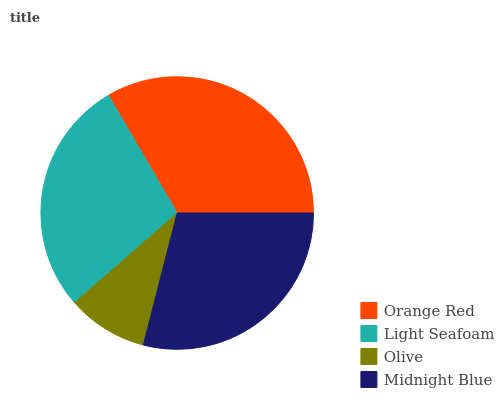Is Olive the minimum?
Answer yes or no. Yes. Is Orange Red the maximum?
Answer yes or no. Yes. Is Light Seafoam the minimum?
Answer yes or no. No. Is Light Seafoam the maximum?
Answer yes or no. No. Is Orange Red greater than Light Seafoam?
Answer yes or no. Yes. Is Light Seafoam less than Orange Red?
Answer yes or no. Yes. Is Light Seafoam greater than Orange Red?
Answer yes or no. No. Is Orange Red less than Light Seafoam?
Answer yes or no. No. Is Midnight Blue the high median?
Answer yes or no. Yes. Is Light Seafoam the low median?
Answer yes or no. Yes. Is Orange Red the high median?
Answer yes or no. No. Is Orange Red the low median?
Answer yes or no. No. 